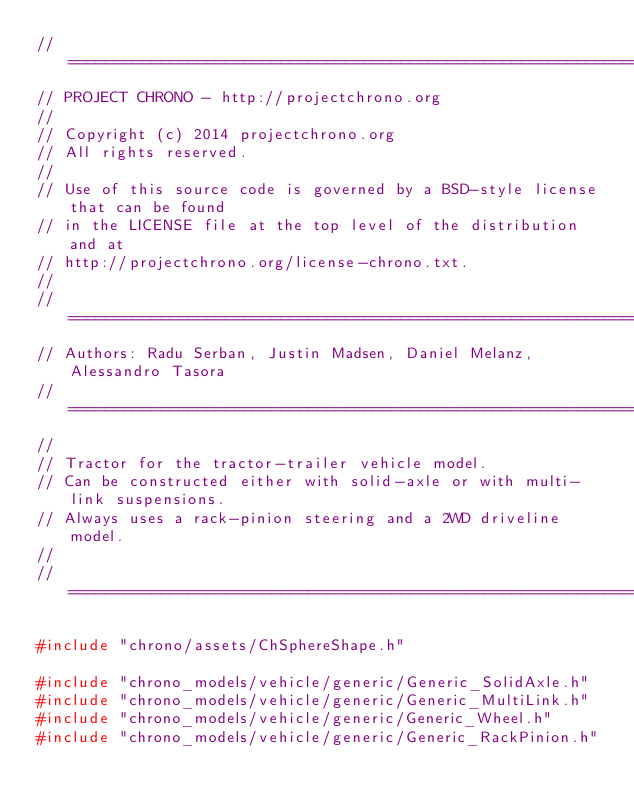Convert code to text. <code><loc_0><loc_0><loc_500><loc_500><_C++_>// =============================================================================
// PROJECT CHRONO - http://projectchrono.org
//
// Copyright (c) 2014 projectchrono.org
// All rights reserved.
//
// Use of this source code is governed by a BSD-style license that can be found
// in the LICENSE file at the top level of the distribution and at
// http://projectchrono.org/license-chrono.txt.
//
// =============================================================================
// Authors: Radu Serban, Justin Madsen, Daniel Melanz, Alessandro Tasora
// =============================================================================
//
// Tractor for the tractor-trailer vehicle model.
// Can be constructed either with solid-axle or with multi-link suspensions.
// Always uses a rack-pinion steering and a 2WD driveline model.
//
// =============================================================================

#include "chrono/assets/ChSphereShape.h"

#include "chrono_models/vehicle/generic/Generic_SolidAxle.h"
#include "chrono_models/vehicle/generic/Generic_MultiLink.h"
#include "chrono_models/vehicle/generic/Generic_Wheel.h"
#include "chrono_models/vehicle/generic/Generic_RackPinion.h"</code> 